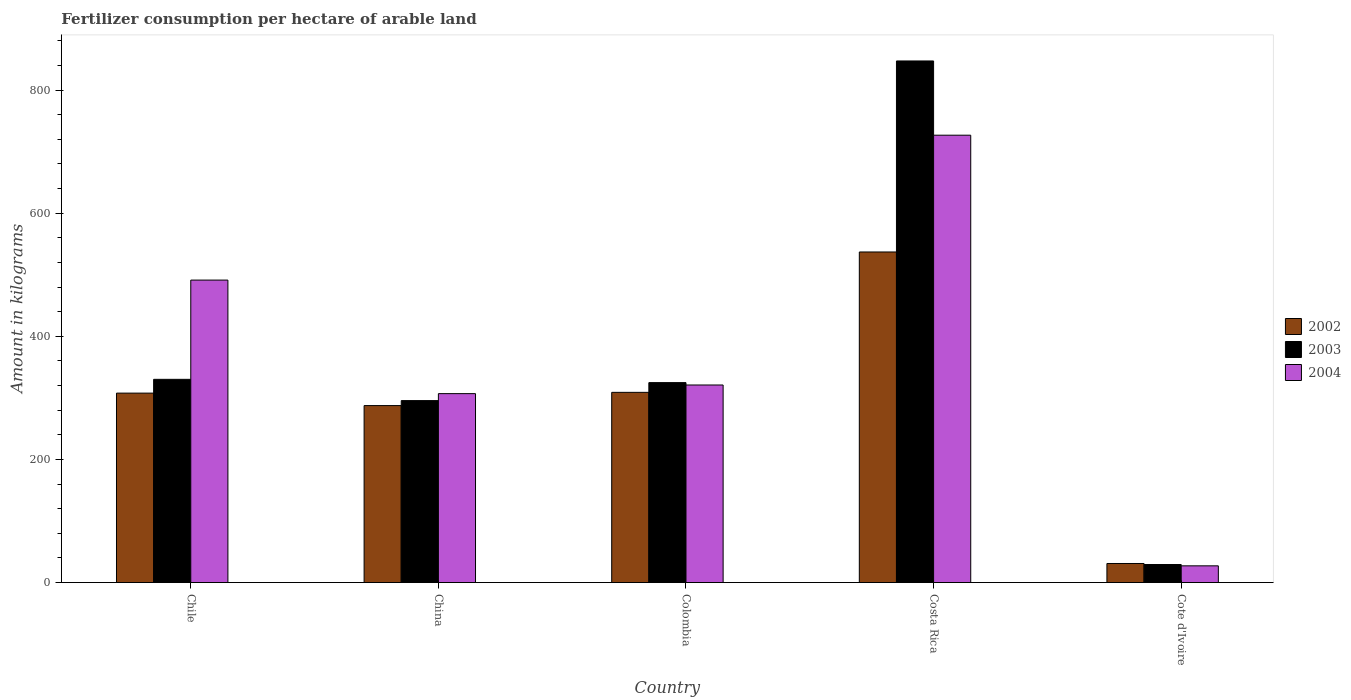Are the number of bars on each tick of the X-axis equal?
Your response must be concise. Yes. How many bars are there on the 2nd tick from the left?
Provide a succinct answer. 3. How many bars are there on the 1st tick from the right?
Make the answer very short. 3. What is the label of the 2nd group of bars from the left?
Give a very brief answer. China. What is the amount of fertilizer consumption in 2002 in Cote d'Ivoire?
Ensure brevity in your answer.  31.02. Across all countries, what is the maximum amount of fertilizer consumption in 2004?
Keep it short and to the point. 726.7. Across all countries, what is the minimum amount of fertilizer consumption in 2004?
Ensure brevity in your answer.  27.22. In which country was the amount of fertilizer consumption in 2003 minimum?
Offer a terse response. Cote d'Ivoire. What is the total amount of fertilizer consumption in 2002 in the graph?
Provide a short and direct response. 1472.31. What is the difference between the amount of fertilizer consumption in 2003 in Chile and that in China?
Provide a succinct answer. 34.55. What is the difference between the amount of fertilizer consumption in 2003 in Colombia and the amount of fertilizer consumption in 2002 in Costa Rica?
Offer a terse response. -212.2. What is the average amount of fertilizer consumption in 2004 per country?
Your response must be concise. 374.63. What is the difference between the amount of fertilizer consumption of/in 2002 and amount of fertilizer consumption of/in 2003 in Cote d'Ivoire?
Offer a very short reply. 1.67. What is the ratio of the amount of fertilizer consumption in 2004 in Chile to that in China?
Your answer should be very brief. 1.6. What is the difference between the highest and the second highest amount of fertilizer consumption in 2002?
Offer a terse response. 229.24. What is the difference between the highest and the lowest amount of fertilizer consumption in 2004?
Provide a succinct answer. 699.48. Is the sum of the amount of fertilizer consumption in 2003 in Costa Rica and Cote d'Ivoire greater than the maximum amount of fertilizer consumption in 2002 across all countries?
Your answer should be very brief. Yes. Is it the case that in every country, the sum of the amount of fertilizer consumption in 2002 and amount of fertilizer consumption in 2004 is greater than the amount of fertilizer consumption in 2003?
Your answer should be very brief. Yes. Are the values on the major ticks of Y-axis written in scientific E-notation?
Ensure brevity in your answer.  No. Does the graph contain any zero values?
Offer a terse response. No. How are the legend labels stacked?
Provide a short and direct response. Vertical. What is the title of the graph?
Your answer should be very brief. Fertilizer consumption per hectare of arable land. What is the label or title of the X-axis?
Offer a very short reply. Country. What is the label or title of the Y-axis?
Your answer should be very brief. Amount in kilograms. What is the Amount in kilograms of 2002 in Chile?
Provide a succinct answer. 307.77. What is the Amount in kilograms of 2003 in Chile?
Ensure brevity in your answer.  330.14. What is the Amount in kilograms in 2004 in Chile?
Give a very brief answer. 491.35. What is the Amount in kilograms in 2002 in China?
Your answer should be very brief. 287.5. What is the Amount in kilograms of 2003 in China?
Keep it short and to the point. 295.6. What is the Amount in kilograms in 2004 in China?
Offer a very short reply. 306.92. What is the Amount in kilograms in 2002 in Colombia?
Keep it short and to the point. 309. What is the Amount in kilograms of 2003 in Colombia?
Keep it short and to the point. 324.81. What is the Amount in kilograms in 2004 in Colombia?
Provide a short and direct response. 320.96. What is the Amount in kilograms in 2002 in Costa Rica?
Give a very brief answer. 537.01. What is the Amount in kilograms in 2003 in Costa Rica?
Provide a short and direct response. 847.29. What is the Amount in kilograms of 2004 in Costa Rica?
Provide a short and direct response. 726.7. What is the Amount in kilograms of 2002 in Cote d'Ivoire?
Your answer should be very brief. 31.02. What is the Amount in kilograms in 2003 in Cote d'Ivoire?
Your response must be concise. 29.35. What is the Amount in kilograms of 2004 in Cote d'Ivoire?
Make the answer very short. 27.22. Across all countries, what is the maximum Amount in kilograms in 2002?
Offer a very short reply. 537.01. Across all countries, what is the maximum Amount in kilograms in 2003?
Ensure brevity in your answer.  847.29. Across all countries, what is the maximum Amount in kilograms in 2004?
Your response must be concise. 726.7. Across all countries, what is the minimum Amount in kilograms in 2002?
Provide a succinct answer. 31.02. Across all countries, what is the minimum Amount in kilograms of 2003?
Your response must be concise. 29.35. Across all countries, what is the minimum Amount in kilograms in 2004?
Offer a very short reply. 27.22. What is the total Amount in kilograms in 2002 in the graph?
Your answer should be compact. 1472.31. What is the total Amount in kilograms of 2003 in the graph?
Give a very brief answer. 1827.18. What is the total Amount in kilograms in 2004 in the graph?
Keep it short and to the point. 1873.15. What is the difference between the Amount in kilograms of 2002 in Chile and that in China?
Offer a terse response. 20.27. What is the difference between the Amount in kilograms in 2003 in Chile and that in China?
Offer a terse response. 34.55. What is the difference between the Amount in kilograms in 2004 in Chile and that in China?
Your answer should be compact. 184.44. What is the difference between the Amount in kilograms of 2002 in Chile and that in Colombia?
Provide a short and direct response. -1.23. What is the difference between the Amount in kilograms of 2003 in Chile and that in Colombia?
Your answer should be very brief. 5.33. What is the difference between the Amount in kilograms in 2004 in Chile and that in Colombia?
Keep it short and to the point. 170.39. What is the difference between the Amount in kilograms of 2002 in Chile and that in Costa Rica?
Provide a succinct answer. -229.24. What is the difference between the Amount in kilograms in 2003 in Chile and that in Costa Rica?
Provide a succinct answer. -517.15. What is the difference between the Amount in kilograms of 2004 in Chile and that in Costa Rica?
Offer a terse response. -235.34. What is the difference between the Amount in kilograms of 2002 in Chile and that in Cote d'Ivoire?
Your response must be concise. 276.75. What is the difference between the Amount in kilograms in 2003 in Chile and that in Cote d'Ivoire?
Your answer should be very brief. 300.8. What is the difference between the Amount in kilograms in 2004 in Chile and that in Cote d'Ivoire?
Give a very brief answer. 464.13. What is the difference between the Amount in kilograms in 2002 in China and that in Colombia?
Your response must be concise. -21.5. What is the difference between the Amount in kilograms of 2003 in China and that in Colombia?
Give a very brief answer. -29.21. What is the difference between the Amount in kilograms of 2004 in China and that in Colombia?
Keep it short and to the point. -14.05. What is the difference between the Amount in kilograms of 2002 in China and that in Costa Rica?
Give a very brief answer. -249.51. What is the difference between the Amount in kilograms in 2003 in China and that in Costa Rica?
Keep it short and to the point. -551.7. What is the difference between the Amount in kilograms of 2004 in China and that in Costa Rica?
Offer a very short reply. -419.78. What is the difference between the Amount in kilograms in 2002 in China and that in Cote d'Ivoire?
Provide a short and direct response. 256.48. What is the difference between the Amount in kilograms in 2003 in China and that in Cote d'Ivoire?
Your answer should be very brief. 266.25. What is the difference between the Amount in kilograms in 2004 in China and that in Cote d'Ivoire?
Ensure brevity in your answer.  279.7. What is the difference between the Amount in kilograms in 2002 in Colombia and that in Costa Rica?
Make the answer very short. -228.01. What is the difference between the Amount in kilograms in 2003 in Colombia and that in Costa Rica?
Offer a terse response. -522.48. What is the difference between the Amount in kilograms of 2004 in Colombia and that in Costa Rica?
Provide a succinct answer. -405.73. What is the difference between the Amount in kilograms of 2002 in Colombia and that in Cote d'Ivoire?
Your answer should be very brief. 277.98. What is the difference between the Amount in kilograms of 2003 in Colombia and that in Cote d'Ivoire?
Offer a very short reply. 295.46. What is the difference between the Amount in kilograms of 2004 in Colombia and that in Cote d'Ivoire?
Keep it short and to the point. 293.74. What is the difference between the Amount in kilograms of 2002 in Costa Rica and that in Cote d'Ivoire?
Offer a terse response. 505.99. What is the difference between the Amount in kilograms of 2003 in Costa Rica and that in Cote d'Ivoire?
Make the answer very short. 817.95. What is the difference between the Amount in kilograms of 2004 in Costa Rica and that in Cote d'Ivoire?
Offer a very short reply. 699.48. What is the difference between the Amount in kilograms in 2002 in Chile and the Amount in kilograms in 2003 in China?
Give a very brief answer. 12.18. What is the difference between the Amount in kilograms in 2002 in Chile and the Amount in kilograms in 2004 in China?
Ensure brevity in your answer.  0.86. What is the difference between the Amount in kilograms of 2003 in Chile and the Amount in kilograms of 2004 in China?
Offer a terse response. 23.23. What is the difference between the Amount in kilograms in 2002 in Chile and the Amount in kilograms in 2003 in Colombia?
Ensure brevity in your answer.  -17.04. What is the difference between the Amount in kilograms of 2002 in Chile and the Amount in kilograms of 2004 in Colombia?
Provide a short and direct response. -13.19. What is the difference between the Amount in kilograms of 2003 in Chile and the Amount in kilograms of 2004 in Colombia?
Offer a very short reply. 9.18. What is the difference between the Amount in kilograms in 2002 in Chile and the Amount in kilograms in 2003 in Costa Rica?
Provide a succinct answer. -539.52. What is the difference between the Amount in kilograms in 2002 in Chile and the Amount in kilograms in 2004 in Costa Rica?
Your answer should be compact. -418.92. What is the difference between the Amount in kilograms in 2003 in Chile and the Amount in kilograms in 2004 in Costa Rica?
Offer a terse response. -396.55. What is the difference between the Amount in kilograms in 2002 in Chile and the Amount in kilograms in 2003 in Cote d'Ivoire?
Ensure brevity in your answer.  278.43. What is the difference between the Amount in kilograms in 2002 in Chile and the Amount in kilograms in 2004 in Cote d'Ivoire?
Offer a very short reply. 280.55. What is the difference between the Amount in kilograms of 2003 in Chile and the Amount in kilograms of 2004 in Cote d'Ivoire?
Offer a terse response. 302.92. What is the difference between the Amount in kilograms in 2002 in China and the Amount in kilograms in 2003 in Colombia?
Make the answer very short. -37.31. What is the difference between the Amount in kilograms of 2002 in China and the Amount in kilograms of 2004 in Colombia?
Provide a short and direct response. -33.46. What is the difference between the Amount in kilograms in 2003 in China and the Amount in kilograms in 2004 in Colombia?
Offer a terse response. -25.37. What is the difference between the Amount in kilograms in 2002 in China and the Amount in kilograms in 2003 in Costa Rica?
Ensure brevity in your answer.  -559.79. What is the difference between the Amount in kilograms of 2002 in China and the Amount in kilograms of 2004 in Costa Rica?
Provide a succinct answer. -439.19. What is the difference between the Amount in kilograms of 2003 in China and the Amount in kilograms of 2004 in Costa Rica?
Make the answer very short. -431.1. What is the difference between the Amount in kilograms of 2002 in China and the Amount in kilograms of 2003 in Cote d'Ivoire?
Make the answer very short. 258.16. What is the difference between the Amount in kilograms of 2002 in China and the Amount in kilograms of 2004 in Cote d'Ivoire?
Your response must be concise. 260.28. What is the difference between the Amount in kilograms in 2003 in China and the Amount in kilograms in 2004 in Cote d'Ivoire?
Your response must be concise. 268.38. What is the difference between the Amount in kilograms in 2002 in Colombia and the Amount in kilograms in 2003 in Costa Rica?
Make the answer very short. -538.29. What is the difference between the Amount in kilograms in 2002 in Colombia and the Amount in kilograms in 2004 in Costa Rica?
Provide a short and direct response. -417.69. What is the difference between the Amount in kilograms in 2003 in Colombia and the Amount in kilograms in 2004 in Costa Rica?
Your response must be concise. -401.89. What is the difference between the Amount in kilograms of 2002 in Colombia and the Amount in kilograms of 2003 in Cote d'Ivoire?
Offer a terse response. 279.66. What is the difference between the Amount in kilograms of 2002 in Colombia and the Amount in kilograms of 2004 in Cote d'Ivoire?
Your answer should be very brief. 281.78. What is the difference between the Amount in kilograms of 2003 in Colombia and the Amount in kilograms of 2004 in Cote d'Ivoire?
Your response must be concise. 297.59. What is the difference between the Amount in kilograms in 2002 in Costa Rica and the Amount in kilograms in 2003 in Cote d'Ivoire?
Your answer should be compact. 507.66. What is the difference between the Amount in kilograms in 2002 in Costa Rica and the Amount in kilograms in 2004 in Cote d'Ivoire?
Offer a terse response. 509.79. What is the difference between the Amount in kilograms in 2003 in Costa Rica and the Amount in kilograms in 2004 in Cote d'Ivoire?
Your answer should be compact. 820.07. What is the average Amount in kilograms of 2002 per country?
Your response must be concise. 294.46. What is the average Amount in kilograms in 2003 per country?
Keep it short and to the point. 365.44. What is the average Amount in kilograms in 2004 per country?
Offer a terse response. 374.63. What is the difference between the Amount in kilograms in 2002 and Amount in kilograms in 2003 in Chile?
Offer a terse response. -22.37. What is the difference between the Amount in kilograms in 2002 and Amount in kilograms in 2004 in Chile?
Offer a terse response. -183.58. What is the difference between the Amount in kilograms of 2003 and Amount in kilograms of 2004 in Chile?
Keep it short and to the point. -161.21. What is the difference between the Amount in kilograms in 2002 and Amount in kilograms in 2003 in China?
Your answer should be very brief. -8.09. What is the difference between the Amount in kilograms in 2002 and Amount in kilograms in 2004 in China?
Your answer should be compact. -19.42. What is the difference between the Amount in kilograms in 2003 and Amount in kilograms in 2004 in China?
Provide a succinct answer. -11.32. What is the difference between the Amount in kilograms of 2002 and Amount in kilograms of 2003 in Colombia?
Offer a terse response. -15.81. What is the difference between the Amount in kilograms of 2002 and Amount in kilograms of 2004 in Colombia?
Your answer should be compact. -11.96. What is the difference between the Amount in kilograms of 2003 and Amount in kilograms of 2004 in Colombia?
Keep it short and to the point. 3.85. What is the difference between the Amount in kilograms in 2002 and Amount in kilograms in 2003 in Costa Rica?
Your response must be concise. -310.28. What is the difference between the Amount in kilograms of 2002 and Amount in kilograms of 2004 in Costa Rica?
Make the answer very short. -189.69. What is the difference between the Amount in kilograms of 2003 and Amount in kilograms of 2004 in Costa Rica?
Provide a succinct answer. 120.6. What is the difference between the Amount in kilograms in 2002 and Amount in kilograms in 2003 in Cote d'Ivoire?
Offer a terse response. 1.67. What is the difference between the Amount in kilograms of 2002 and Amount in kilograms of 2004 in Cote d'Ivoire?
Give a very brief answer. 3.8. What is the difference between the Amount in kilograms in 2003 and Amount in kilograms in 2004 in Cote d'Ivoire?
Offer a terse response. 2.13. What is the ratio of the Amount in kilograms of 2002 in Chile to that in China?
Provide a short and direct response. 1.07. What is the ratio of the Amount in kilograms of 2003 in Chile to that in China?
Your answer should be very brief. 1.12. What is the ratio of the Amount in kilograms of 2004 in Chile to that in China?
Offer a terse response. 1.6. What is the ratio of the Amount in kilograms of 2002 in Chile to that in Colombia?
Provide a succinct answer. 1. What is the ratio of the Amount in kilograms in 2003 in Chile to that in Colombia?
Your response must be concise. 1.02. What is the ratio of the Amount in kilograms of 2004 in Chile to that in Colombia?
Provide a short and direct response. 1.53. What is the ratio of the Amount in kilograms in 2002 in Chile to that in Costa Rica?
Provide a short and direct response. 0.57. What is the ratio of the Amount in kilograms in 2003 in Chile to that in Costa Rica?
Your answer should be compact. 0.39. What is the ratio of the Amount in kilograms in 2004 in Chile to that in Costa Rica?
Your response must be concise. 0.68. What is the ratio of the Amount in kilograms of 2002 in Chile to that in Cote d'Ivoire?
Your answer should be compact. 9.92. What is the ratio of the Amount in kilograms of 2003 in Chile to that in Cote d'Ivoire?
Offer a terse response. 11.25. What is the ratio of the Amount in kilograms in 2004 in Chile to that in Cote d'Ivoire?
Provide a succinct answer. 18.05. What is the ratio of the Amount in kilograms in 2002 in China to that in Colombia?
Your answer should be compact. 0.93. What is the ratio of the Amount in kilograms of 2003 in China to that in Colombia?
Give a very brief answer. 0.91. What is the ratio of the Amount in kilograms of 2004 in China to that in Colombia?
Keep it short and to the point. 0.96. What is the ratio of the Amount in kilograms of 2002 in China to that in Costa Rica?
Offer a very short reply. 0.54. What is the ratio of the Amount in kilograms of 2003 in China to that in Costa Rica?
Your answer should be compact. 0.35. What is the ratio of the Amount in kilograms in 2004 in China to that in Costa Rica?
Offer a terse response. 0.42. What is the ratio of the Amount in kilograms of 2002 in China to that in Cote d'Ivoire?
Make the answer very short. 9.27. What is the ratio of the Amount in kilograms of 2003 in China to that in Cote d'Ivoire?
Make the answer very short. 10.07. What is the ratio of the Amount in kilograms of 2004 in China to that in Cote d'Ivoire?
Your answer should be very brief. 11.28. What is the ratio of the Amount in kilograms in 2002 in Colombia to that in Costa Rica?
Provide a succinct answer. 0.58. What is the ratio of the Amount in kilograms of 2003 in Colombia to that in Costa Rica?
Ensure brevity in your answer.  0.38. What is the ratio of the Amount in kilograms of 2004 in Colombia to that in Costa Rica?
Provide a succinct answer. 0.44. What is the ratio of the Amount in kilograms of 2002 in Colombia to that in Cote d'Ivoire?
Your answer should be compact. 9.96. What is the ratio of the Amount in kilograms of 2003 in Colombia to that in Cote d'Ivoire?
Make the answer very short. 11.07. What is the ratio of the Amount in kilograms in 2004 in Colombia to that in Cote d'Ivoire?
Your answer should be very brief. 11.79. What is the ratio of the Amount in kilograms in 2002 in Costa Rica to that in Cote d'Ivoire?
Provide a short and direct response. 17.31. What is the ratio of the Amount in kilograms of 2003 in Costa Rica to that in Cote d'Ivoire?
Your answer should be very brief. 28.87. What is the ratio of the Amount in kilograms in 2004 in Costa Rica to that in Cote d'Ivoire?
Ensure brevity in your answer.  26.7. What is the difference between the highest and the second highest Amount in kilograms in 2002?
Ensure brevity in your answer.  228.01. What is the difference between the highest and the second highest Amount in kilograms of 2003?
Offer a terse response. 517.15. What is the difference between the highest and the second highest Amount in kilograms of 2004?
Offer a very short reply. 235.34. What is the difference between the highest and the lowest Amount in kilograms in 2002?
Keep it short and to the point. 505.99. What is the difference between the highest and the lowest Amount in kilograms of 2003?
Provide a succinct answer. 817.95. What is the difference between the highest and the lowest Amount in kilograms of 2004?
Give a very brief answer. 699.48. 